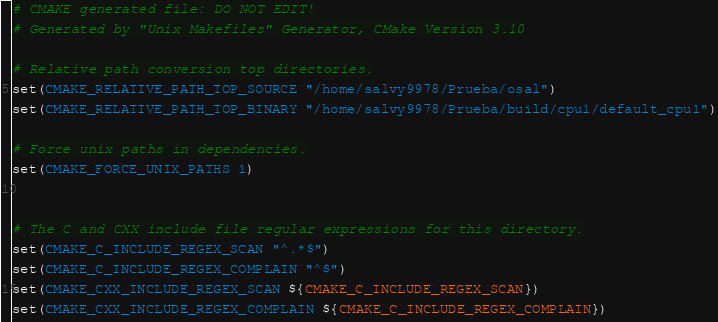<code> <loc_0><loc_0><loc_500><loc_500><_CMake_># CMAKE generated file: DO NOT EDIT!
# Generated by "Unix Makefiles" Generator, CMake Version 3.10

# Relative path conversion top directories.
set(CMAKE_RELATIVE_PATH_TOP_SOURCE "/home/salvy9978/Prueba/osal")
set(CMAKE_RELATIVE_PATH_TOP_BINARY "/home/salvy9978/Prueba/build/cpu1/default_cpu1")

# Force unix paths in dependencies.
set(CMAKE_FORCE_UNIX_PATHS 1)


# The C and CXX include file regular expressions for this directory.
set(CMAKE_C_INCLUDE_REGEX_SCAN "^.*$")
set(CMAKE_C_INCLUDE_REGEX_COMPLAIN "^$")
set(CMAKE_CXX_INCLUDE_REGEX_SCAN ${CMAKE_C_INCLUDE_REGEX_SCAN})
set(CMAKE_CXX_INCLUDE_REGEX_COMPLAIN ${CMAKE_C_INCLUDE_REGEX_COMPLAIN})
</code> 